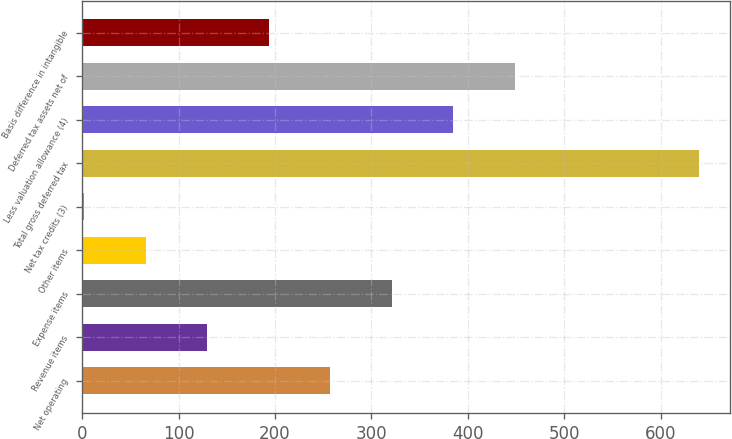Convert chart. <chart><loc_0><loc_0><loc_500><loc_500><bar_chart><fcel>Net operating<fcel>Revenue items<fcel>Expense items<fcel>Other items<fcel>Net tax credits (3)<fcel>Total gross deferred tax<fcel>Less valuation allowance (4)<fcel>Deferred tax assets net of<fcel>Basis difference in intangible<nl><fcel>257.2<fcel>129.6<fcel>321<fcel>65.8<fcel>2<fcel>640<fcel>384.8<fcel>448.6<fcel>193.4<nl></chart> 